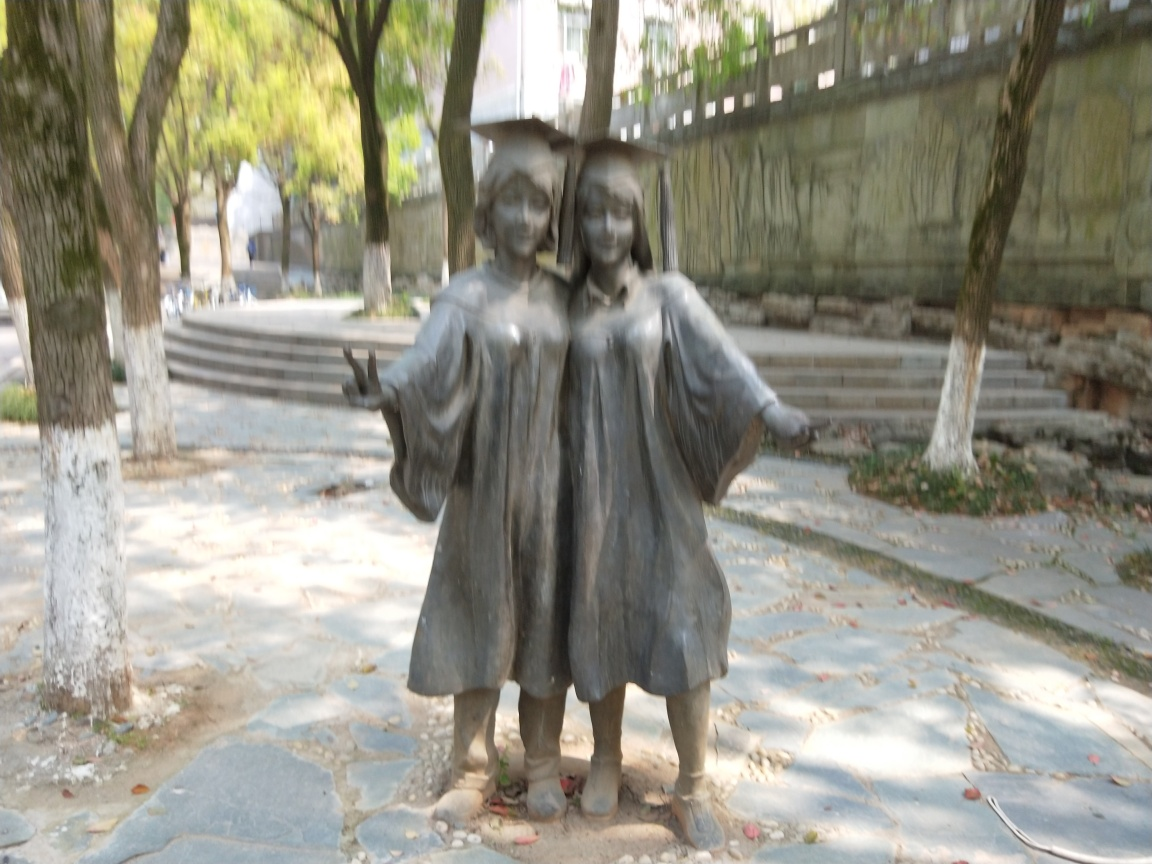What can you tell me about the environment surrounding the statue? The statue is set in an outdoor environment with plenty of vegetation, which can be seen through the blurred background. We can observe trees and what appears to be a pathway made of stones or tiles, leading towards a set of stairs. The setting is tranquil, and it seems like a shared public space, possibly a park or a public garden, where such a statue would invite passersby to reflect or simply enjoy the pairing of art with nature. 